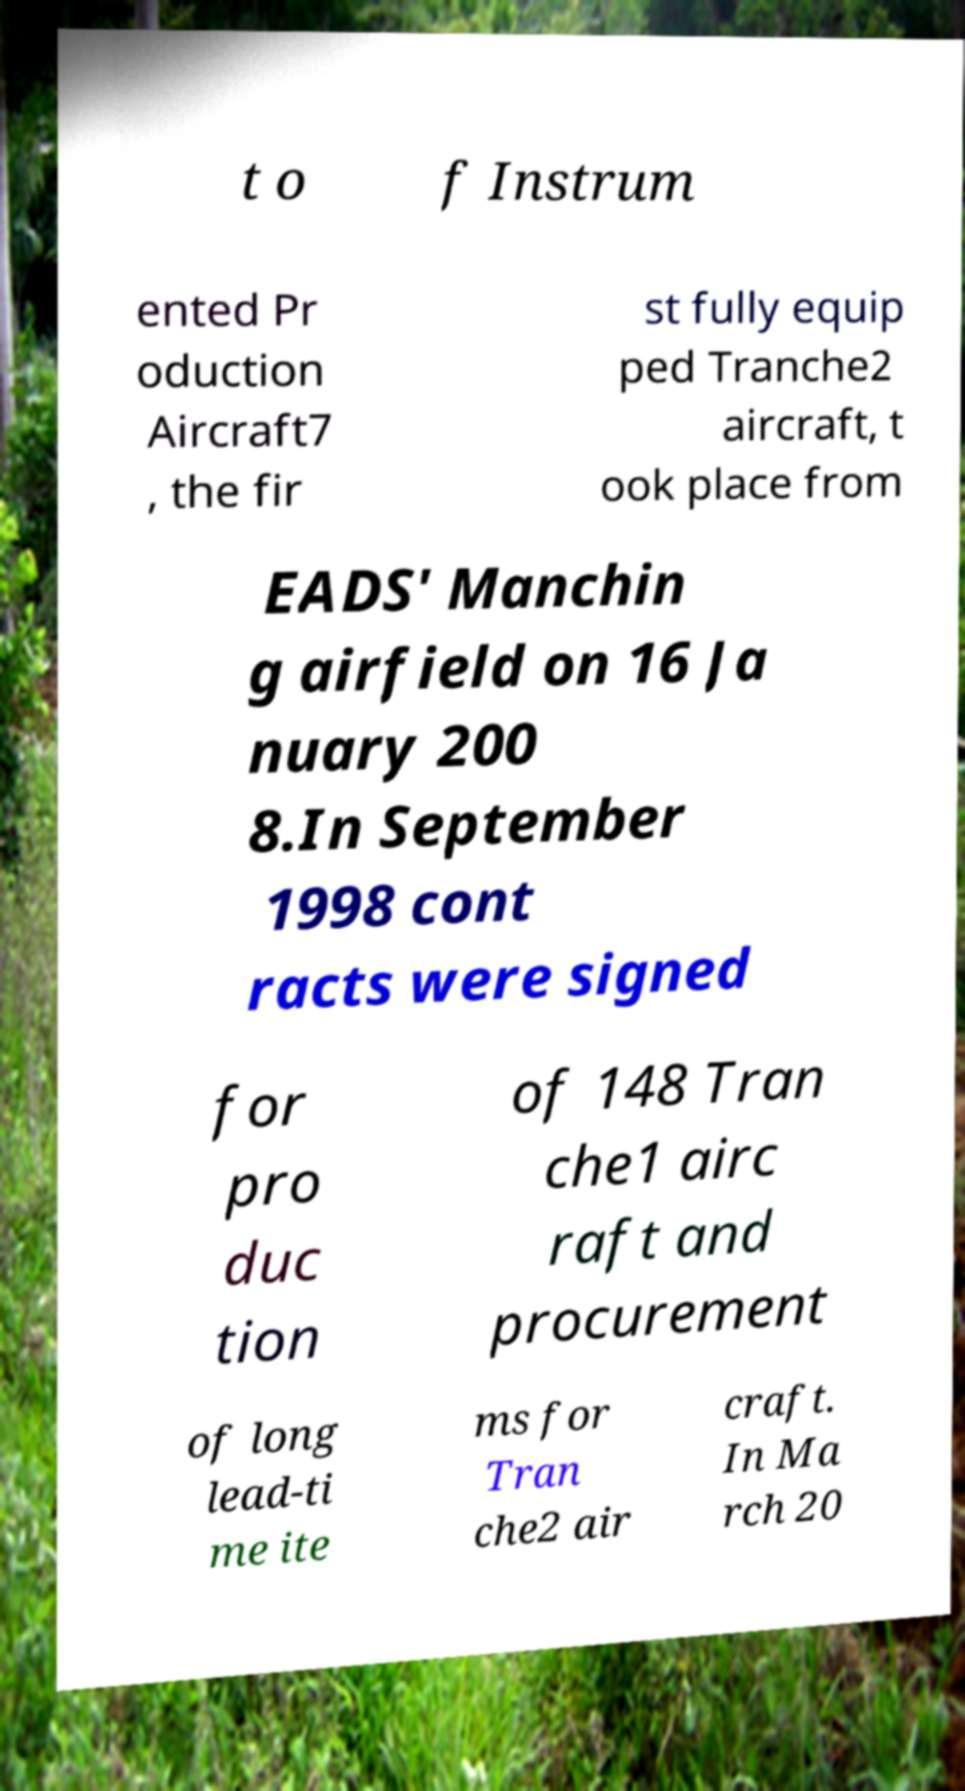Could you assist in decoding the text presented in this image and type it out clearly? t o f Instrum ented Pr oduction Aircraft7 , the fir st fully equip ped Tranche2 aircraft, t ook place from EADS' Manchin g airfield on 16 Ja nuary 200 8.In September 1998 cont racts were signed for pro duc tion of 148 Tran che1 airc raft and procurement of long lead-ti me ite ms for Tran che2 air craft. In Ma rch 20 